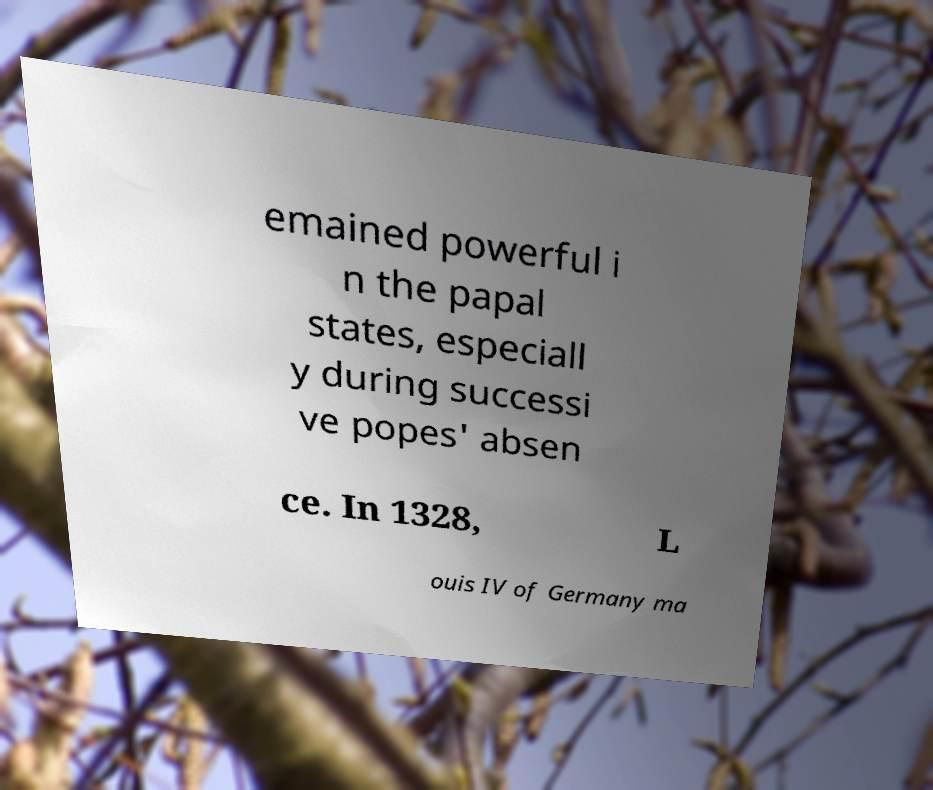Can you accurately transcribe the text from the provided image for me? emained powerful i n the papal states, especiall y during successi ve popes' absen ce. In 1328, L ouis IV of Germany ma 